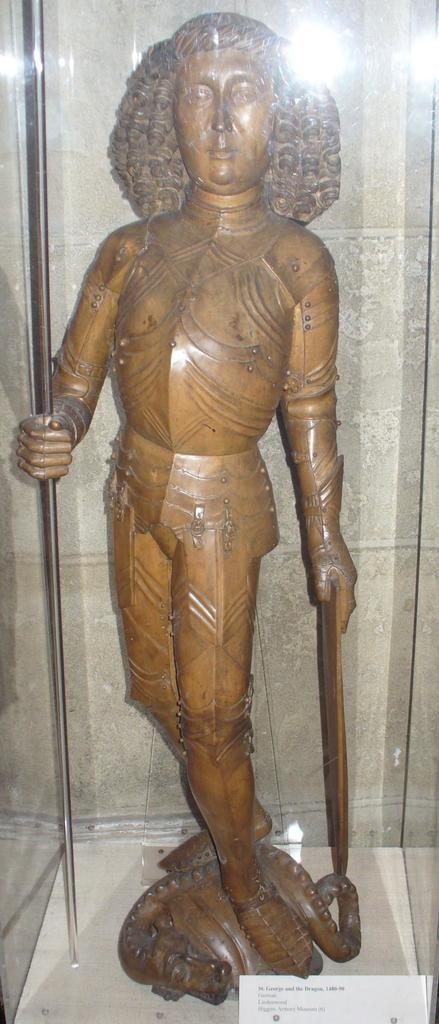What is the main subject of the image? The main subject of the image is a statue. How is the statue displayed in the image? The statue is inside a glass box. Is there any information about the statue provided in the image? Yes, there is a name plate at the bottom of the glass box. Can you see any cables attached to the statue in the image? There are no cables visible in the image; the statue is inside a glass box. Is the statue sinking in quicksand in the image? There is no quicksand present in the image; the statue is inside a glass box. 